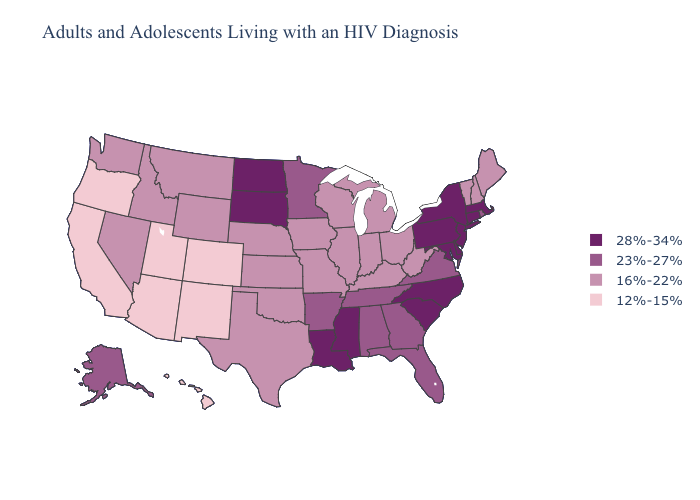What is the highest value in the USA?
Quick response, please. 28%-34%. Does Oklahoma have the same value as Texas?
Write a very short answer. Yes. What is the lowest value in the South?
Give a very brief answer. 16%-22%. Does New Mexico have the same value as Arizona?
Short answer required. Yes. Does Connecticut have the same value as Missouri?
Concise answer only. No. Which states have the lowest value in the Northeast?
Short answer required. Maine, New Hampshire, Vermont. Is the legend a continuous bar?
Write a very short answer. No. What is the value of Kentucky?
Give a very brief answer. 16%-22%. Does California have a lower value than Wisconsin?
Write a very short answer. Yes. Does Wisconsin have the lowest value in the USA?
Quick response, please. No. Does the map have missing data?
Be succinct. No. What is the lowest value in states that border Alabama?
Answer briefly. 23%-27%. Among the states that border Colorado , which have the highest value?
Give a very brief answer. Kansas, Nebraska, Oklahoma, Wyoming. Name the states that have a value in the range 12%-15%?
Answer briefly. Arizona, California, Colorado, Hawaii, New Mexico, Oregon, Utah. What is the lowest value in the West?
Concise answer only. 12%-15%. 